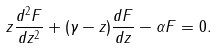Convert formula to latex. <formula><loc_0><loc_0><loc_500><loc_500>z \frac { d ^ { 2 } F } { d z ^ { 2 } } + ( \gamma - z ) \frac { d F } { d z } - \alpha F & = 0 .</formula> 